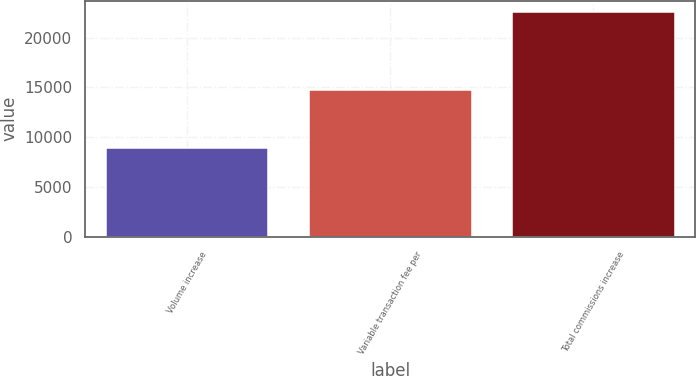Convert chart. <chart><loc_0><loc_0><loc_500><loc_500><bar_chart><fcel>Volume increase<fcel>Variable transaction fee per<fcel>Total commissions increase<nl><fcel>8950<fcel>14727<fcel>22604<nl></chart> 